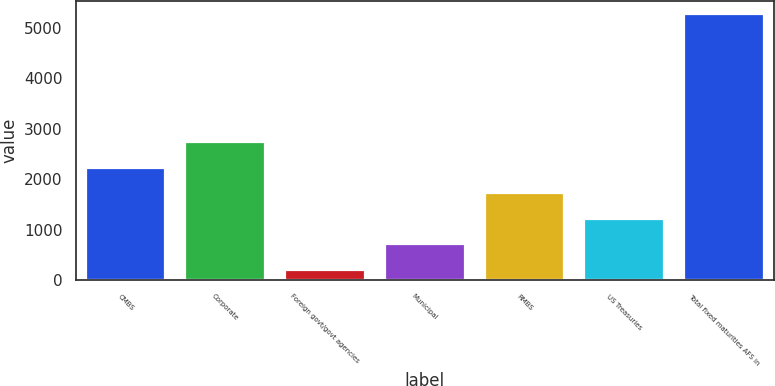<chart> <loc_0><loc_0><loc_500><loc_500><bar_chart><fcel>CMBS<fcel>Corporate<fcel>Foreign govt/govt agencies<fcel>Municipal<fcel>RMBS<fcel>US Treasuries<fcel>Total fixed maturities AFS in<nl><fcel>2230.6<fcel>2737.5<fcel>203<fcel>709.9<fcel>1723.7<fcel>1216.8<fcel>5272<nl></chart> 